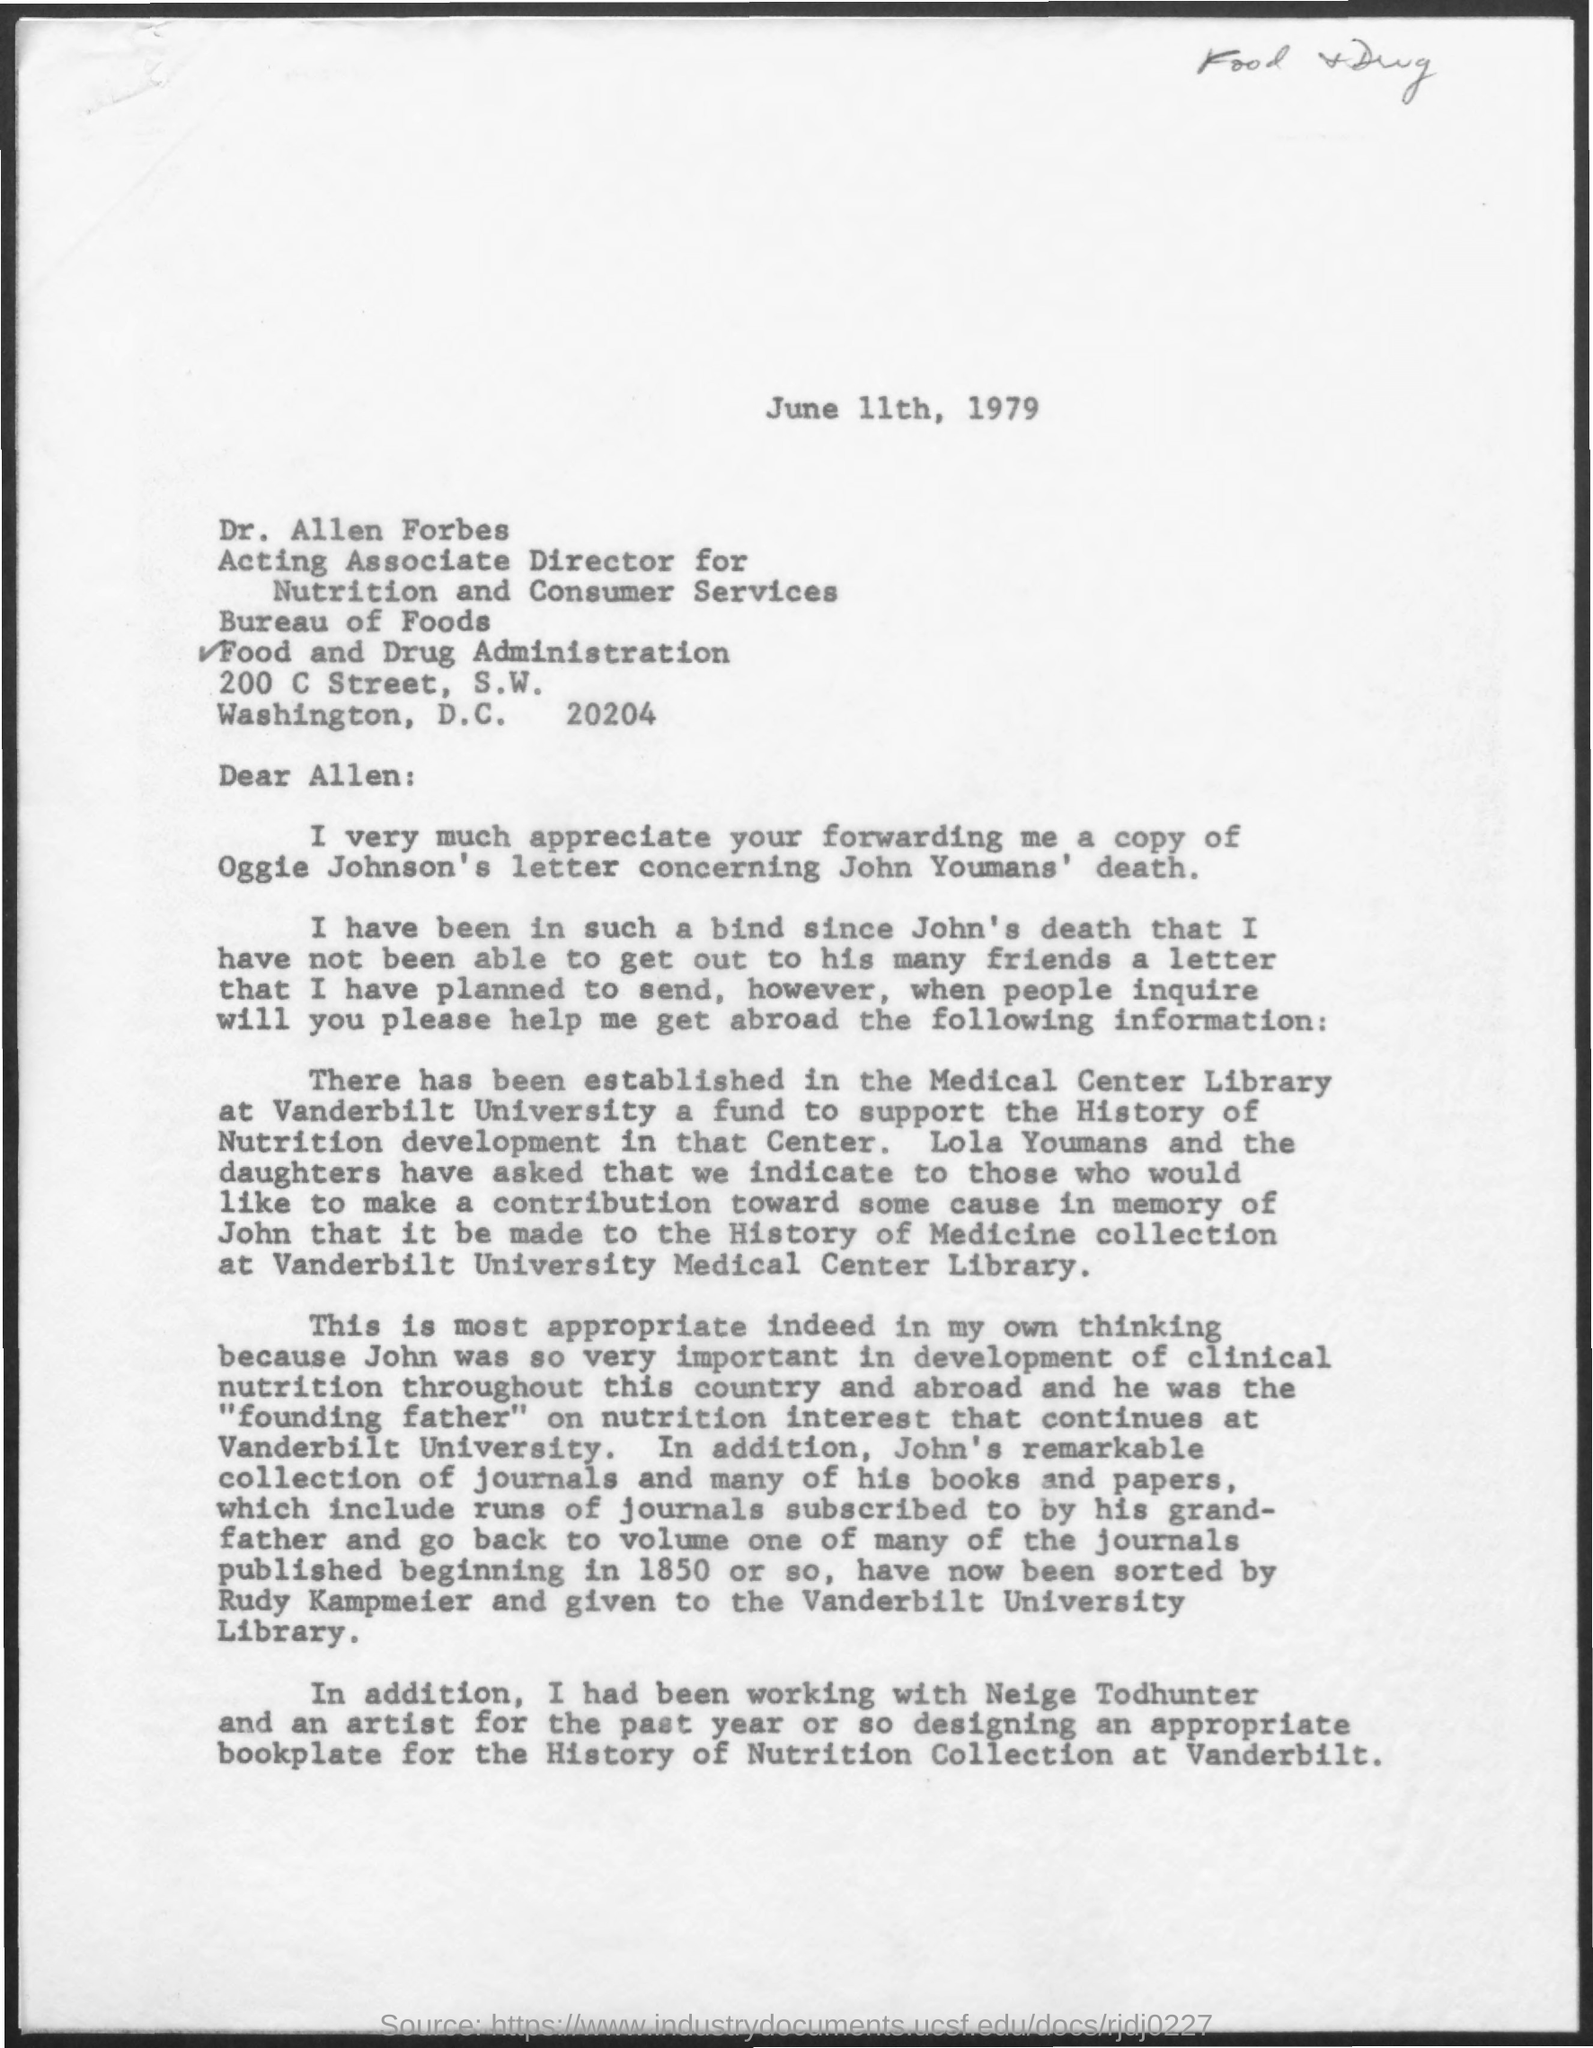Indicate a few pertinent items in this graphic. The issued date of this letter is June 11th, 1979. 